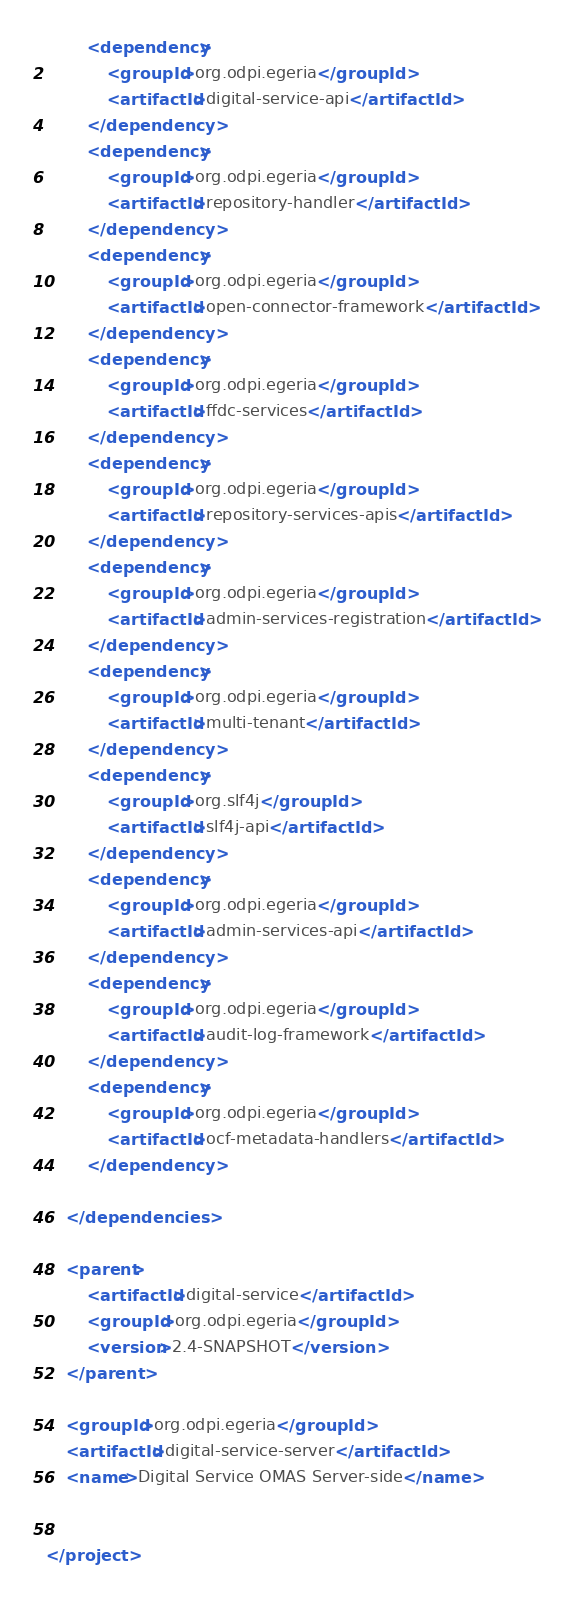<code> <loc_0><loc_0><loc_500><loc_500><_XML_>        <dependency>
            <groupId>org.odpi.egeria</groupId>
            <artifactId>digital-service-api</artifactId>
        </dependency>
        <dependency>
            <groupId>org.odpi.egeria</groupId>
            <artifactId>repository-handler</artifactId>
        </dependency>
        <dependency>
            <groupId>org.odpi.egeria</groupId>
            <artifactId>open-connector-framework</artifactId>
        </dependency>
        <dependency>
            <groupId>org.odpi.egeria</groupId>
            <artifactId>ffdc-services</artifactId>
        </dependency>
        <dependency>
            <groupId>org.odpi.egeria</groupId>
            <artifactId>repository-services-apis</artifactId>
        </dependency>
        <dependency>
            <groupId>org.odpi.egeria</groupId>
            <artifactId>admin-services-registration</artifactId>
        </dependency>
        <dependency>
            <groupId>org.odpi.egeria</groupId>
            <artifactId>multi-tenant</artifactId>
        </dependency>
        <dependency>
            <groupId>org.slf4j</groupId>
            <artifactId>slf4j-api</artifactId>
        </dependency>
        <dependency>
            <groupId>org.odpi.egeria</groupId>
            <artifactId>admin-services-api</artifactId>
        </dependency>
        <dependency>
            <groupId>org.odpi.egeria</groupId>
            <artifactId>audit-log-framework</artifactId>
        </dependency>
        <dependency>
            <groupId>org.odpi.egeria</groupId>
            <artifactId>ocf-metadata-handlers</artifactId>
        </dependency>

    </dependencies>

    <parent>
        <artifactId>digital-service</artifactId>
        <groupId>org.odpi.egeria</groupId>
        <version>2.4-SNAPSHOT</version>
    </parent>

    <groupId>org.odpi.egeria</groupId>
    <artifactId>digital-service-server</artifactId>
    <name>Digital Service OMAS Server-side</name>


</project>
</code> 